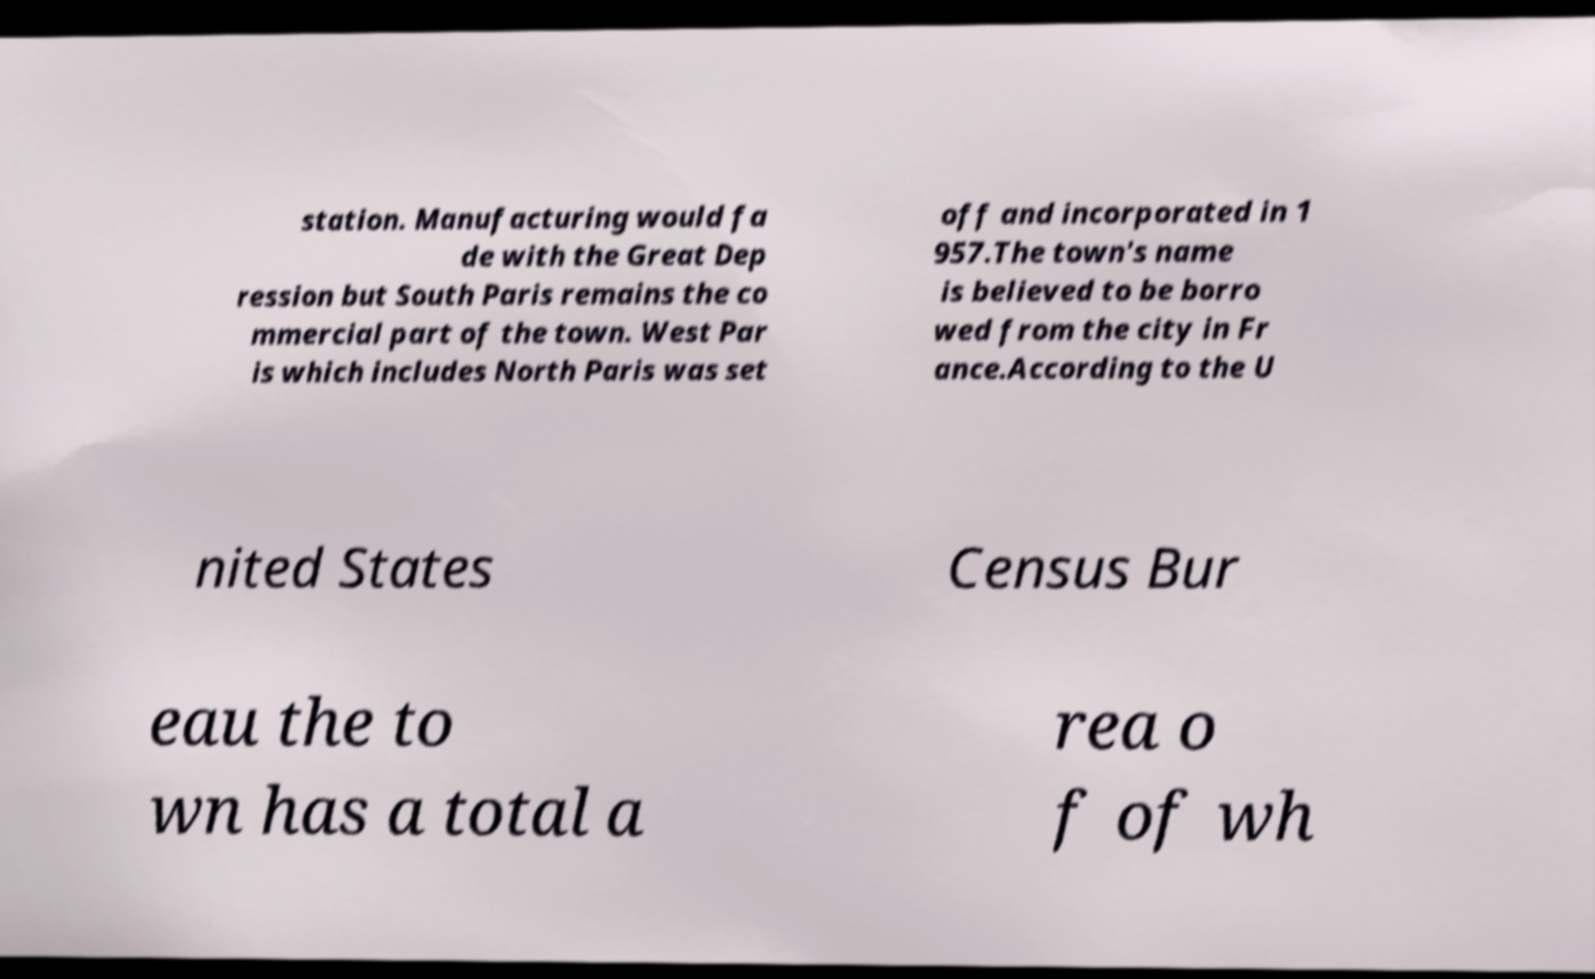For documentation purposes, I need the text within this image transcribed. Could you provide that? station. Manufacturing would fa de with the Great Dep ression but South Paris remains the co mmercial part of the town. West Par is which includes North Paris was set off and incorporated in 1 957.The town's name is believed to be borro wed from the city in Fr ance.According to the U nited States Census Bur eau the to wn has a total a rea o f of wh 